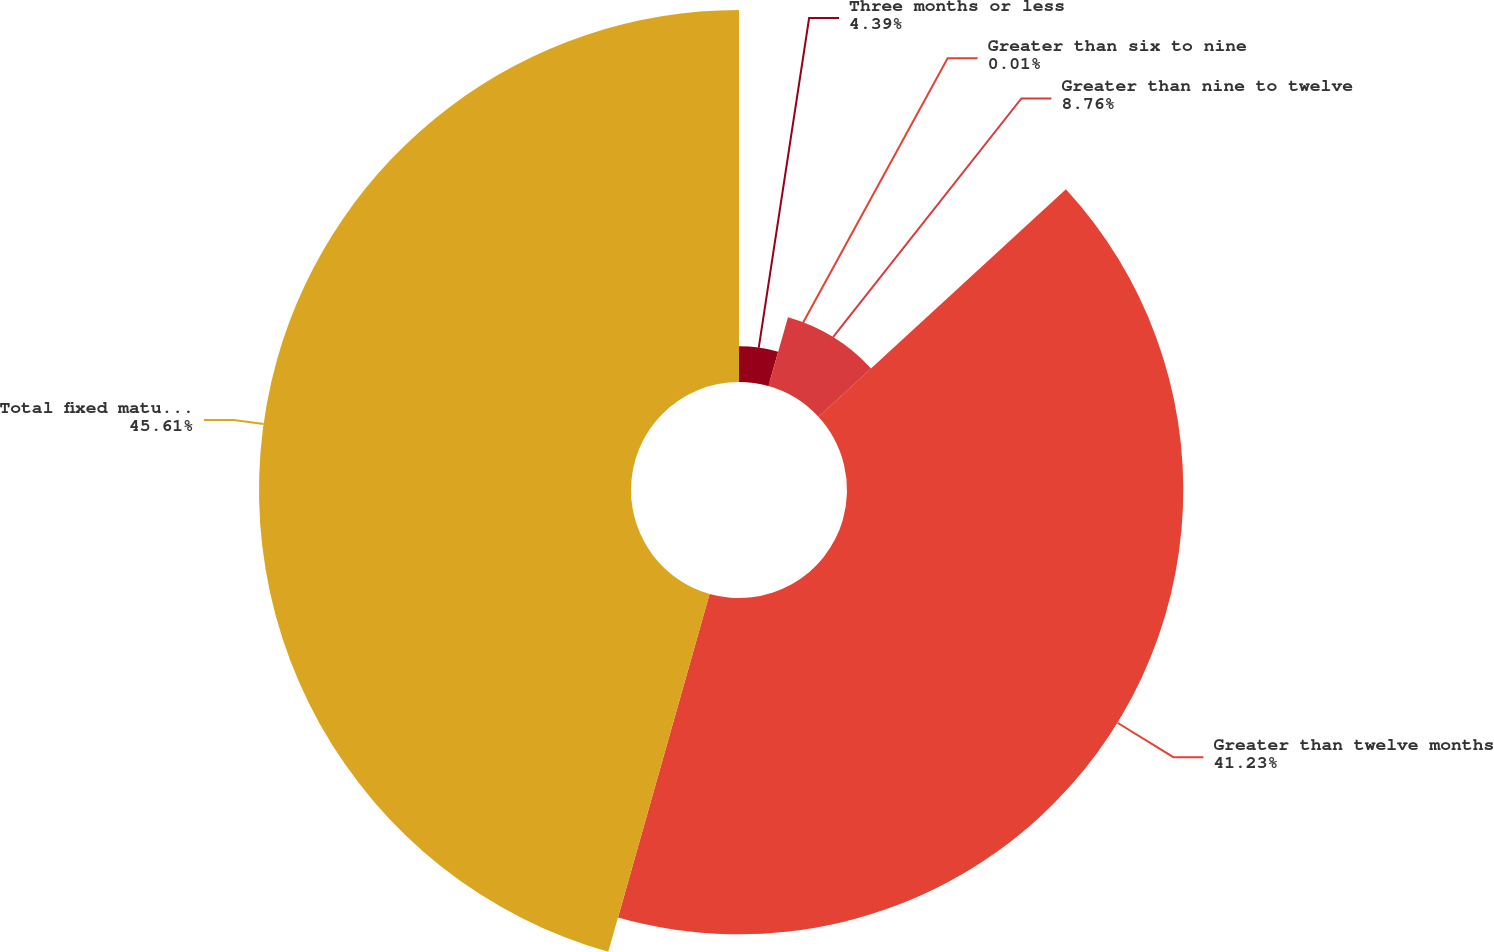Convert chart. <chart><loc_0><loc_0><loc_500><loc_500><pie_chart><fcel>Three months or less<fcel>Greater than six to nine<fcel>Greater than nine to twelve<fcel>Greater than twelve months<fcel>Total fixed maturities<nl><fcel>4.39%<fcel>0.01%<fcel>8.76%<fcel>41.23%<fcel>45.61%<nl></chart> 